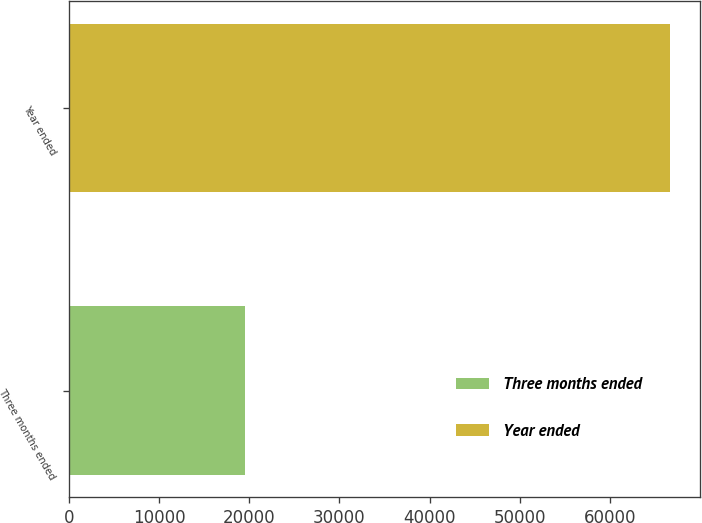<chart> <loc_0><loc_0><loc_500><loc_500><bar_chart><fcel>Three months ended<fcel>Year ended<nl><fcel>19506<fcel>66635<nl></chart> 